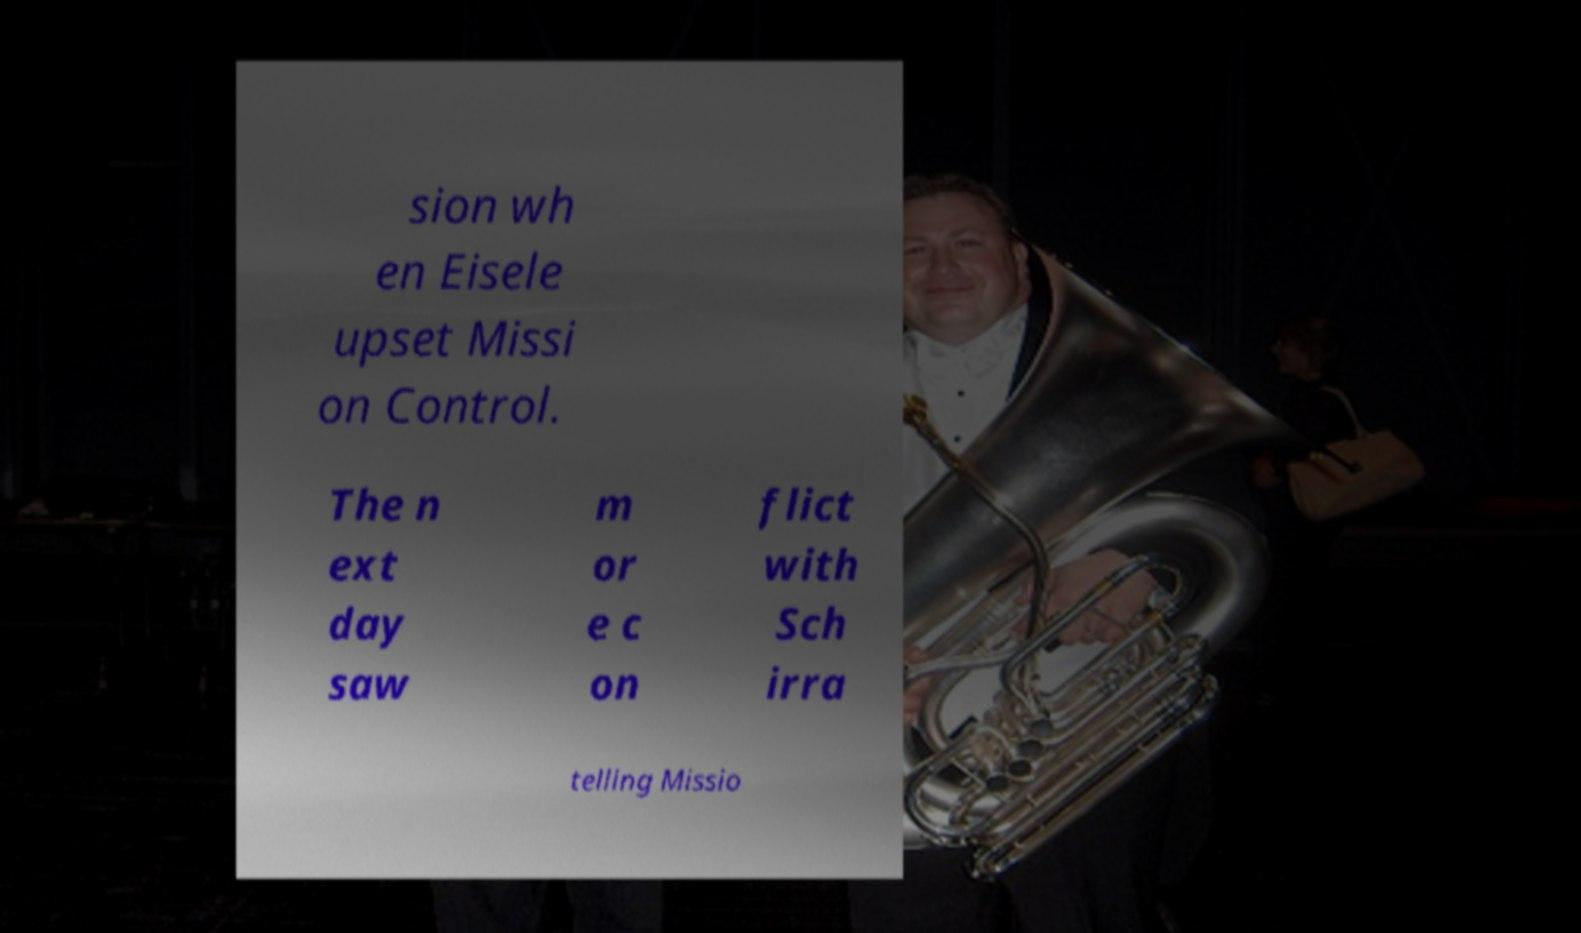Could you extract and type out the text from this image? sion wh en Eisele upset Missi on Control. The n ext day saw m or e c on flict with Sch irra telling Missio 